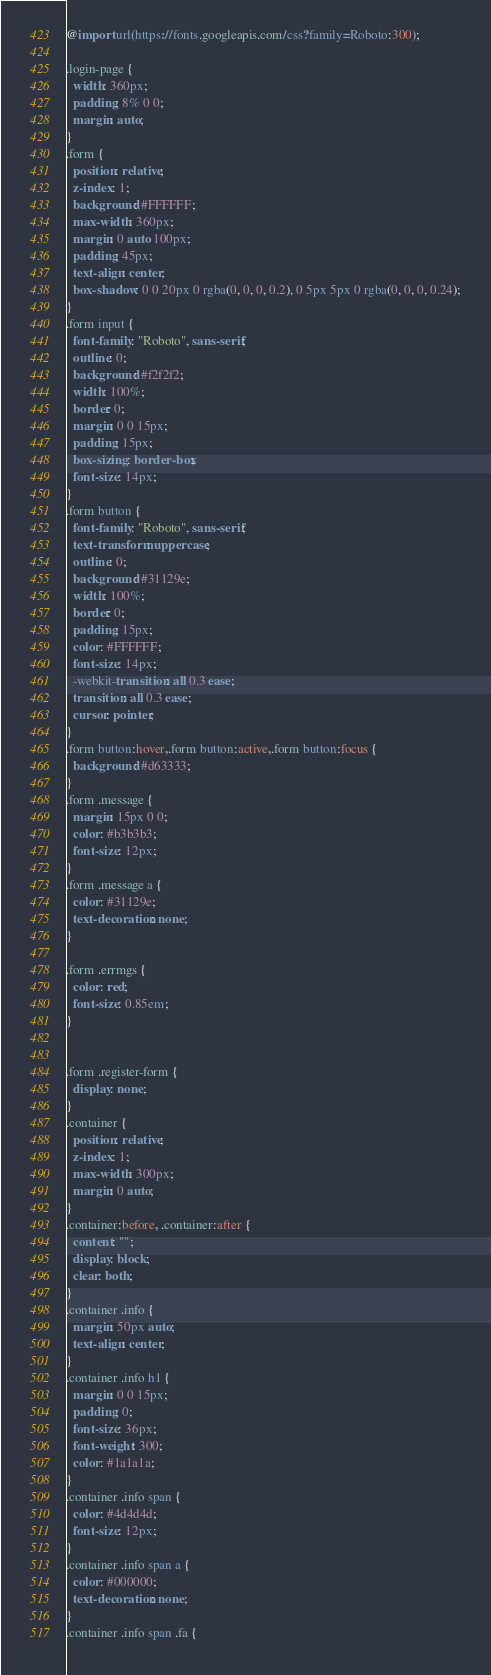Convert code to text. <code><loc_0><loc_0><loc_500><loc_500><_CSS_>@import url(https://fonts.googleapis.com/css?family=Roboto:300);

.login-page {
  width: 360px;
  padding: 8% 0 0;
  margin: auto;
}
.form {
  position: relative;
  z-index: 1;
  background: #FFFFFF;
  max-width: 360px;
  margin: 0 auto 100px;
  padding: 45px;
  text-align: center;
  box-shadow: 0 0 20px 0 rgba(0, 0, 0, 0.2), 0 5px 5px 0 rgba(0, 0, 0, 0.24);
}
.form input {
  font-family: "Roboto", sans-serif;
  outline: 0;
  background: #f2f2f2;
  width: 100%;
  border: 0;
  margin: 0 0 15px;
  padding: 15px;
  box-sizing: border-box;
  font-size: 14px;
}
.form button {
  font-family: "Roboto", sans-serif;
  text-transform: uppercase;
  outline: 0;
  background: #31129e;
  width: 100%;
  border: 0;
  padding: 15px;
  color: #FFFFFF;
  font-size: 14px;
  -webkit-transition: all 0.3 ease;
  transition: all 0.3 ease;
  cursor: pointer;
}
.form button:hover,.form button:active,.form button:focus {
  background: #d63333;
}
.form .message {
  margin: 15px 0 0;
  color: #b3b3b3;
  font-size: 12px;
}
.form .message a {
  color: #31129e;
  text-decoration: none;
}

.form .errmgs {
  color: red;
  font-size: 0.85em;
}


.form .register-form {
  display: none;
}
.container {
  position: relative;
  z-index: 1;
  max-width: 300px;
  margin: 0 auto;
}
.container:before, .container:after {
  content: "";
  display: block;
  clear: both;
}
.container .info {
  margin: 50px auto;
  text-align: center;
}
.container .info h1 {
  margin: 0 0 15px;
  padding: 0;
  font-size: 36px;
  font-weight: 300;
  color: #1a1a1a;
}
.container .info span {
  color: #4d4d4d;
  font-size: 12px;
}
.container .info span a {
  color: #000000;
  text-decoration: none;
}
.container .info span .fa {</code> 